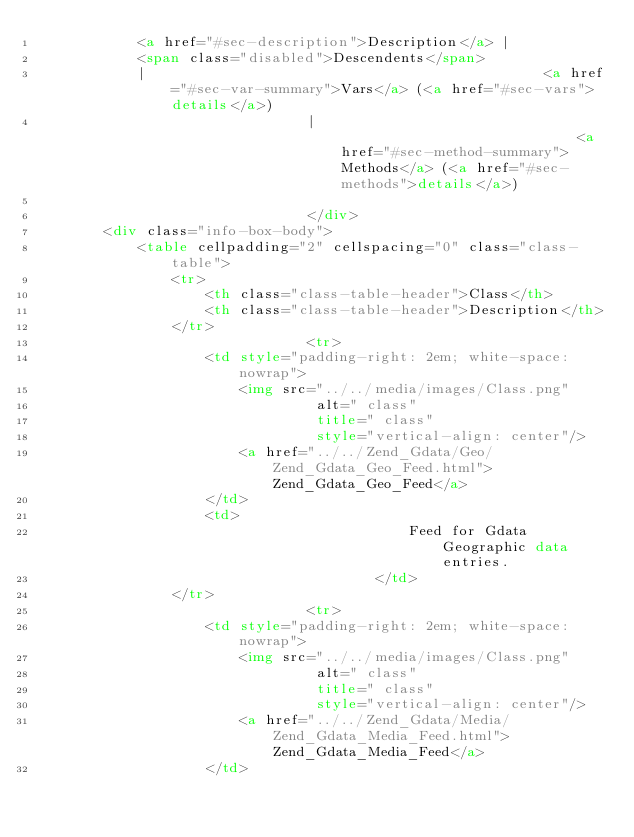Convert code to text. <code><loc_0><loc_0><loc_500><loc_500><_HTML_>			<a href="#sec-description">Description</a> |
			<span class="disabled">Descendents</span>
			|												<a href="#sec-var-summary">Vars</a> (<a href="#sec-vars">details</a>)
								|															<a href="#sec-method-summary">Methods</a> (<a href="#sec-methods">details</a>)
							
								</div>
		<div class="info-box-body">
			<table cellpadding="2" cellspacing="0" class="class-table">
				<tr>
					<th class="class-table-header">Class</th>
					<th class="class-table-header">Description</th>
				</tr>
								<tr>
					<td style="padding-right: 2em; white-space: nowrap">
						<img src="../../media/images/Class.png"
								 alt=" class"
								 title=" class"
								 style="vertical-align: center"/>
						<a href="../../Zend_Gdata/Geo/Zend_Gdata_Geo_Feed.html">Zend_Gdata_Geo_Feed</a>
					</td>
					<td>
											Feed for Gdata Geographic data entries.
										</td>
				</tr>
								<tr>
					<td style="padding-right: 2em; white-space: nowrap">
						<img src="../../media/images/Class.png"
								 alt=" class"
								 title=" class"
								 style="vertical-align: center"/>
						<a href="../../Zend_Gdata/Media/Zend_Gdata_Media_Feed.html">Zend_Gdata_Media_Feed</a>
					</td></code> 